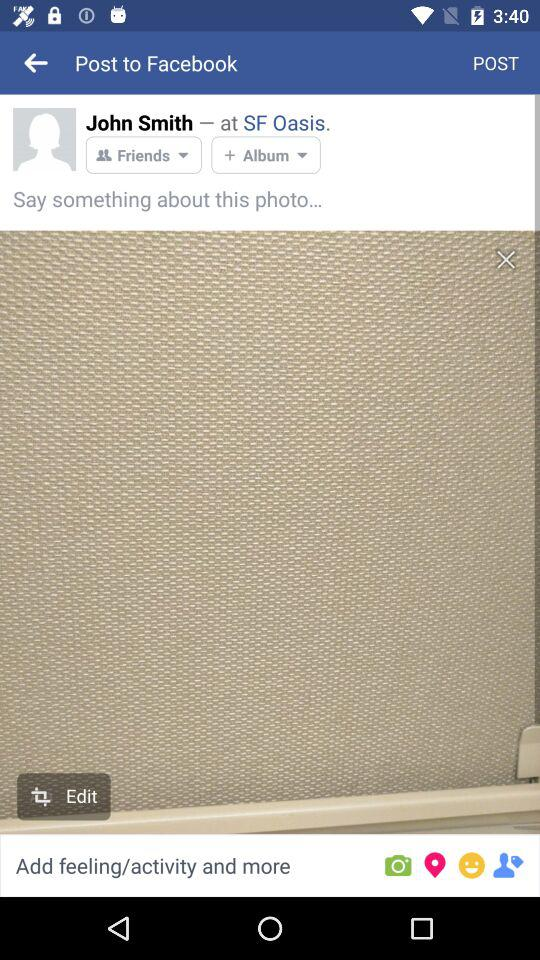What is the name of the user? The name of the user is John Smith. 